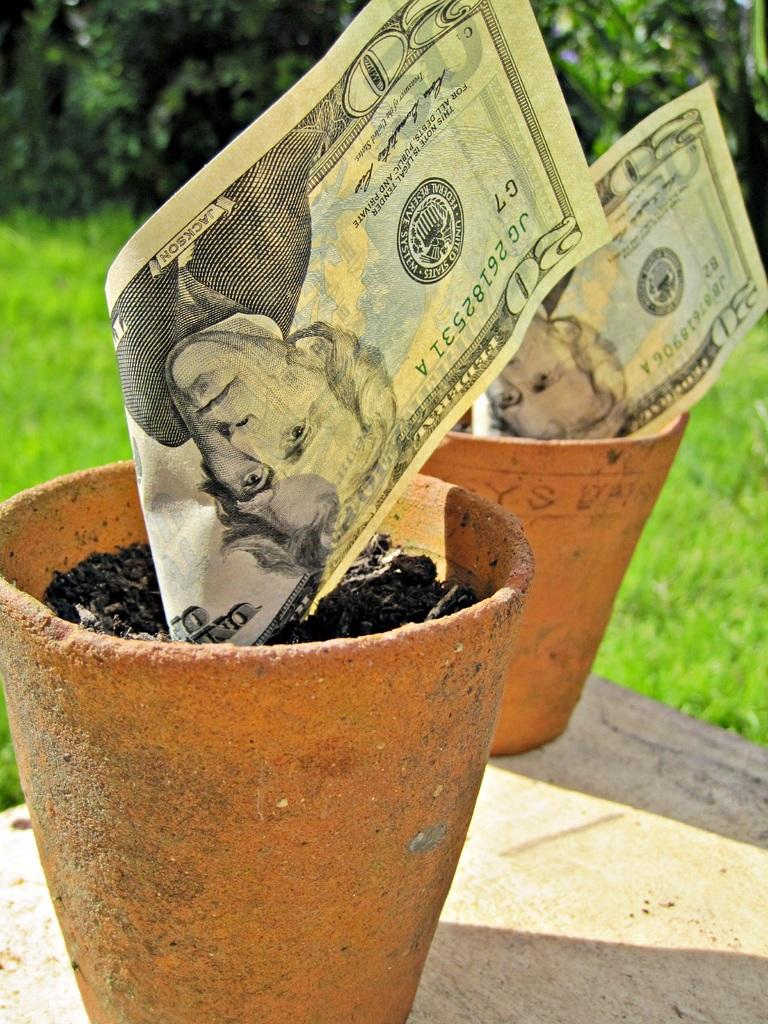What is placed on the flower pots in the image? There are currency notes on the flower pots in the image. Can you describe the background of the image? The background of the image is blurred. What type of tail can be seen on the rat in the image? There is no rat present in the image, so there is no tail to be seen. 